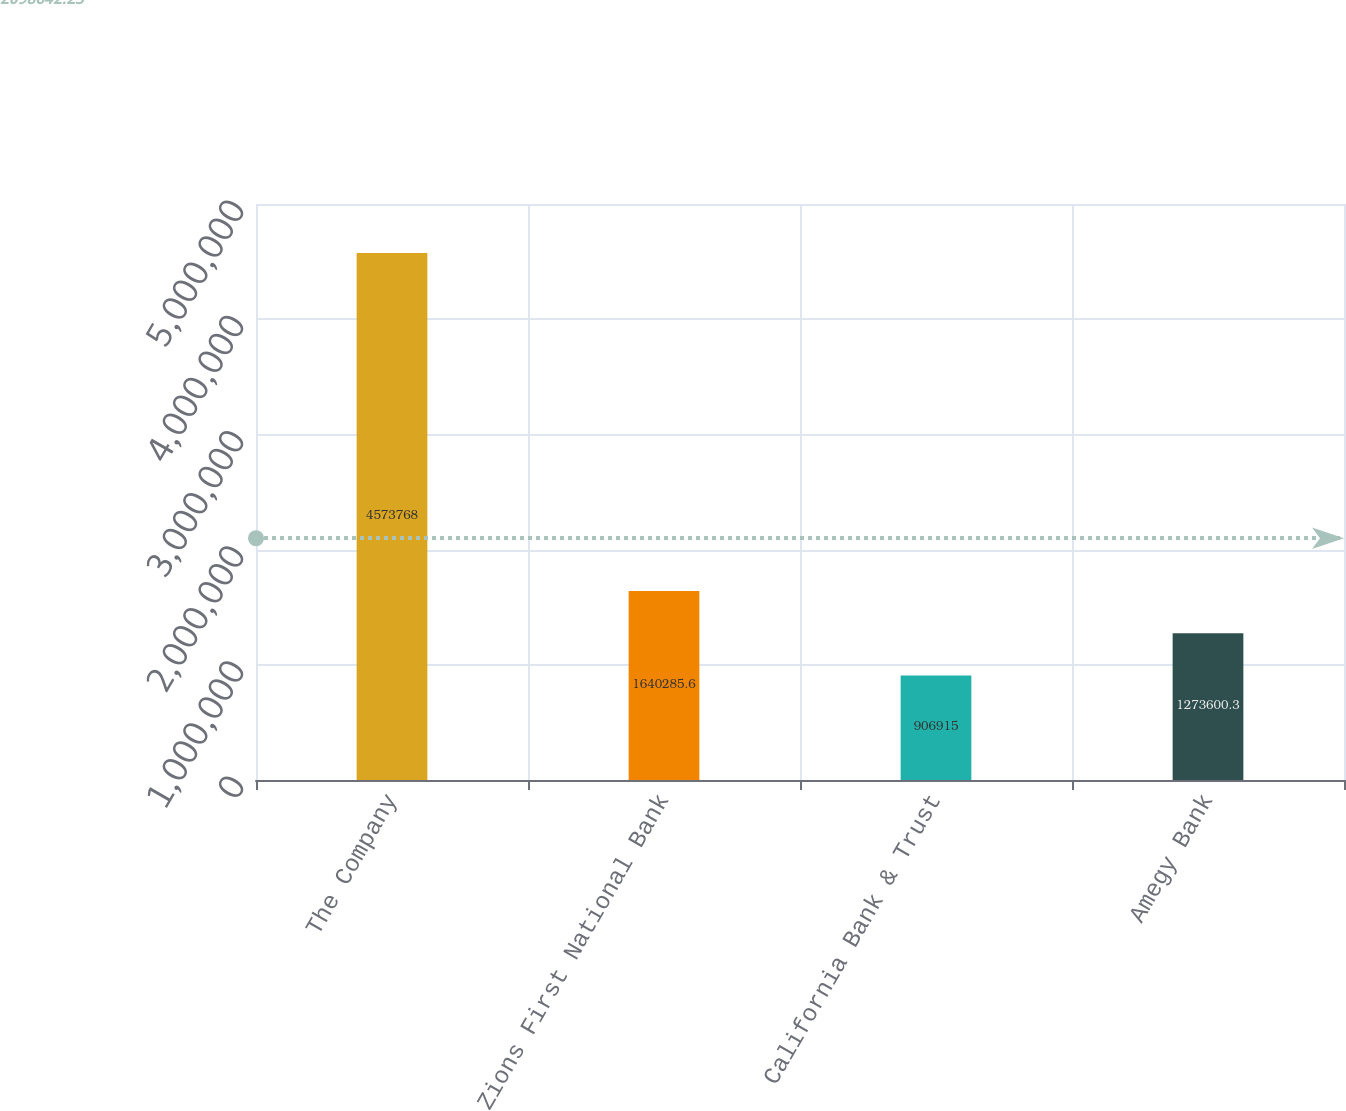Convert chart. <chart><loc_0><loc_0><loc_500><loc_500><bar_chart><fcel>The Company<fcel>Zions First National Bank<fcel>California Bank & Trust<fcel>Amegy Bank<nl><fcel>4.57377e+06<fcel>1.64029e+06<fcel>906915<fcel>1.2736e+06<nl></chart> 